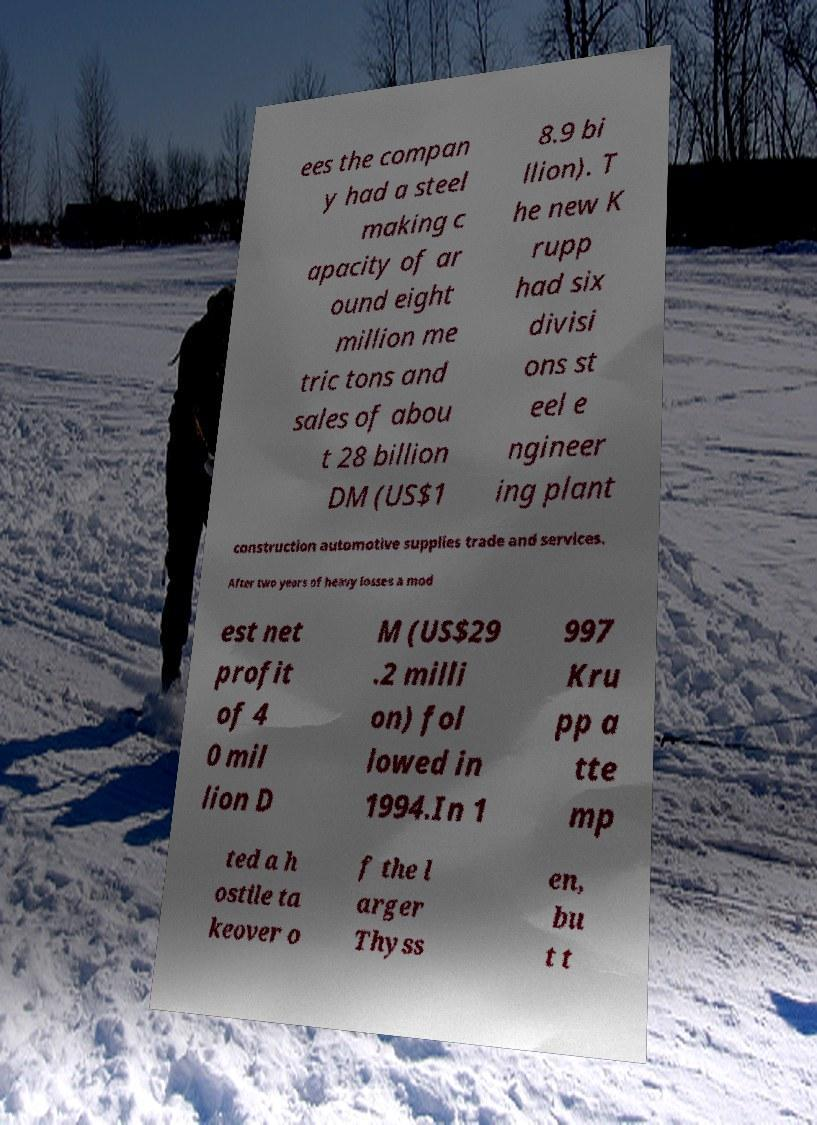Could you assist in decoding the text presented in this image and type it out clearly? ees the compan y had a steel making c apacity of ar ound eight million me tric tons and sales of abou t 28 billion DM (US$1 8.9 bi llion). T he new K rupp had six divisi ons st eel e ngineer ing plant construction automotive supplies trade and services. After two years of heavy losses a mod est net profit of 4 0 mil lion D M (US$29 .2 milli on) fol lowed in 1994.In 1 997 Kru pp a tte mp ted a h ostile ta keover o f the l arger Thyss en, bu t t 